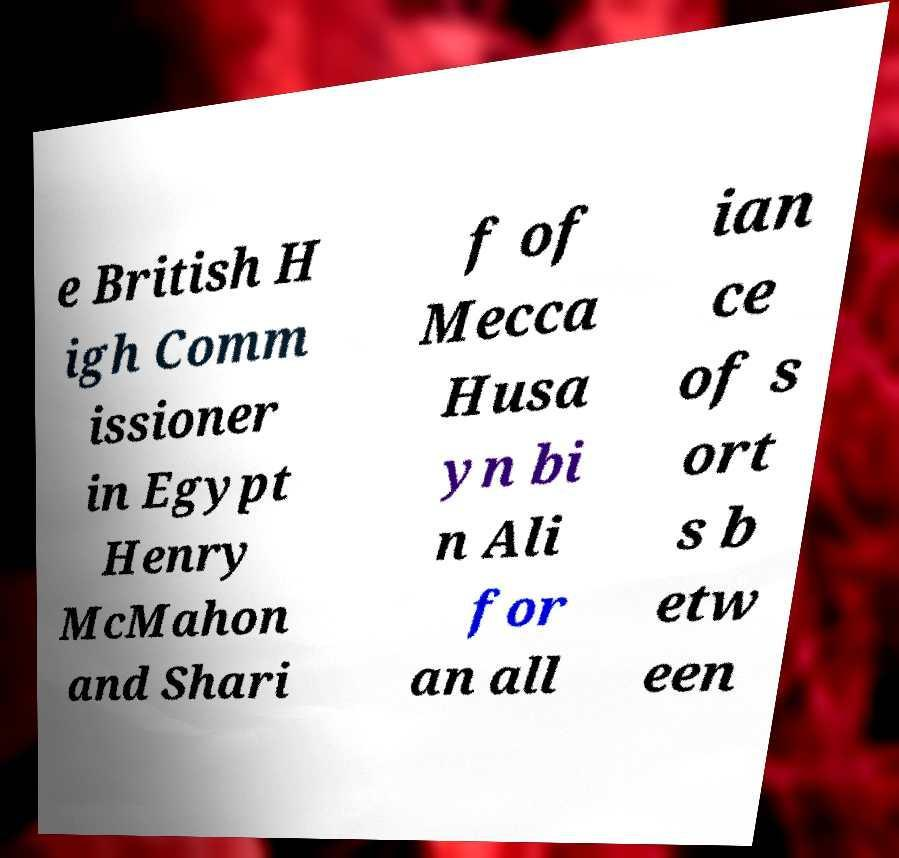Can you accurately transcribe the text from the provided image for me? e British H igh Comm issioner in Egypt Henry McMahon and Shari f of Mecca Husa yn bi n Ali for an all ian ce of s ort s b etw een 